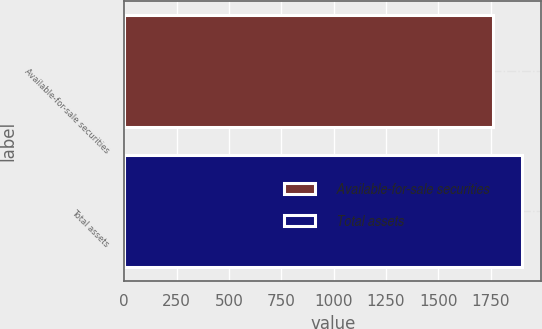Convert chart. <chart><loc_0><loc_0><loc_500><loc_500><bar_chart><fcel>Available-for-sale securities<fcel>Total assets<nl><fcel>1762<fcel>1897<nl></chart> 